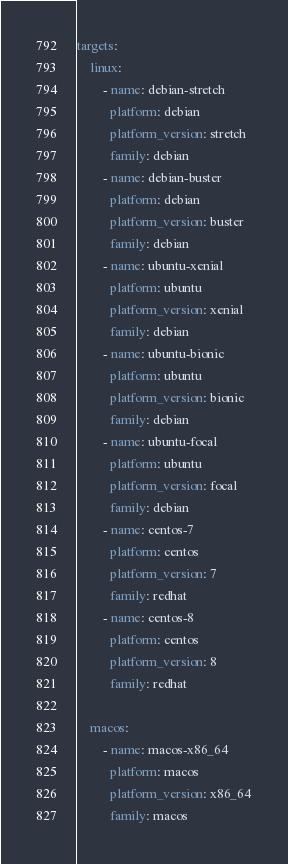Convert code to text. <code><loc_0><loc_0><loc_500><loc_500><_YAML_>targets:
    linux:
        - name: debian-stretch
          platform: debian
          platform_version: stretch
          family: debian
        - name: debian-buster
          platform: debian
          platform_version: buster
          family: debian
        - name: ubuntu-xenial
          platform: ubuntu
          platform_version: xenial
          family: debian
        - name: ubuntu-bionic
          platform: ubuntu
          platform_version: bionic
          family: debian
        - name: ubuntu-focal
          platform: ubuntu
          platform_version: focal
          family: debian
        - name: centos-7
          platform: centos
          platform_version: 7
          family: redhat
        - name: centos-8
          platform: centos
          platform_version: 8
          family: redhat

    macos:
        - name: macos-x86_64
          platform: macos
          platform_version: x86_64
          family: macos
</code> 